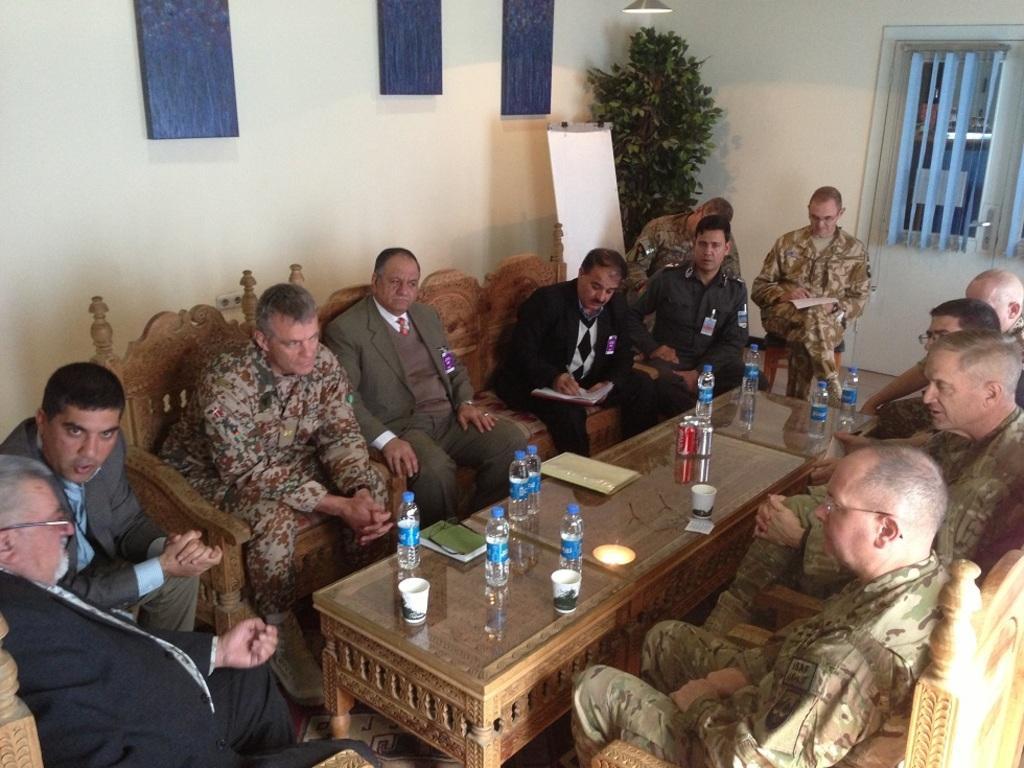Can you describe this image briefly? On the background we can see wall, plant, window with curtains, white board and a light. Here we can see all the persons sitting on chairs in front of a table and few are writing on a paper. On the table we can see dairy, glasses, water bottles, tins. This is a floor carpet. 